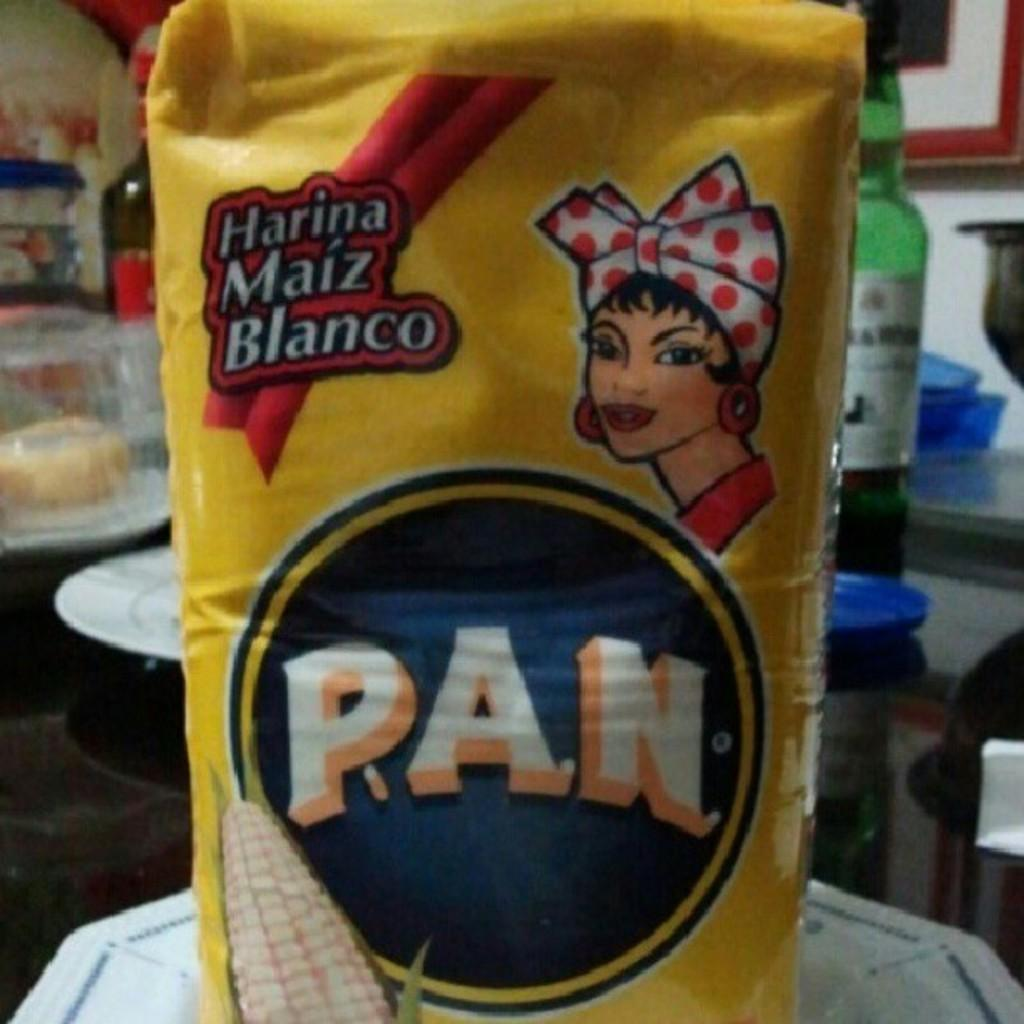<image>
Create a compact narrative representing the image presented. A yellow rectangular bag of PAN with an image of a woman in a kerchief on the top right. 